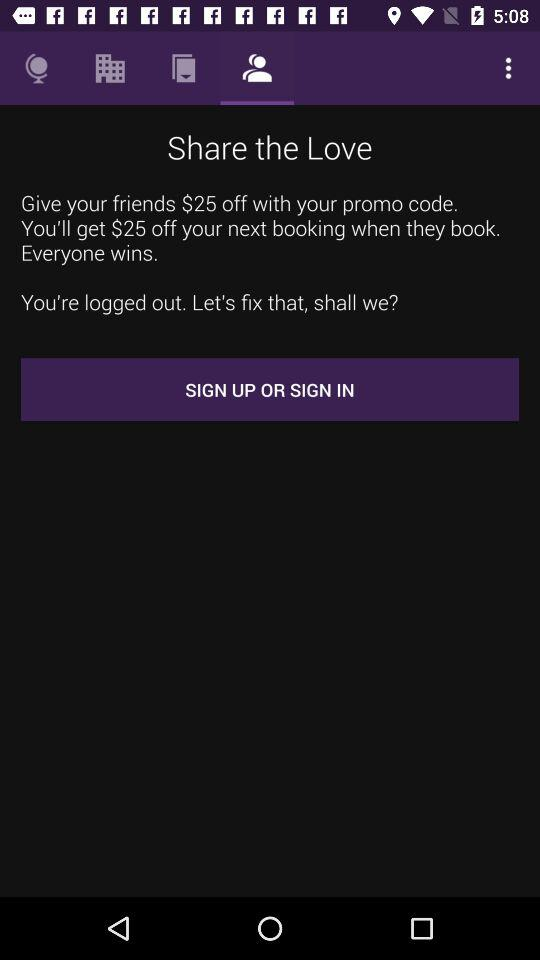Which tab has been selected? The selected tab is "Friends". 